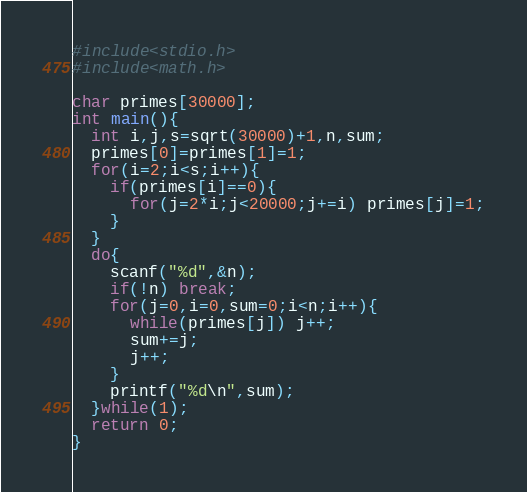Convert code to text. <code><loc_0><loc_0><loc_500><loc_500><_C_>#include<stdio.h>
#include<math.h>

char primes[30000];
int main(){
  int i,j,s=sqrt(30000)+1,n,sum;
  primes[0]=primes[1]=1;
  for(i=2;i<s;i++){
    if(primes[i]==0){
      for(j=2*i;j<20000;j+=i) primes[j]=1;
    }
  }
  do{
    scanf("%d",&n);
    if(!n) break;
    for(j=0,i=0,sum=0;i<n;i++){
      while(primes[j]) j++;
      sum+=j;
      j++;
    }
    printf("%d\n",sum);
  }while(1);
  return 0;
}</code> 